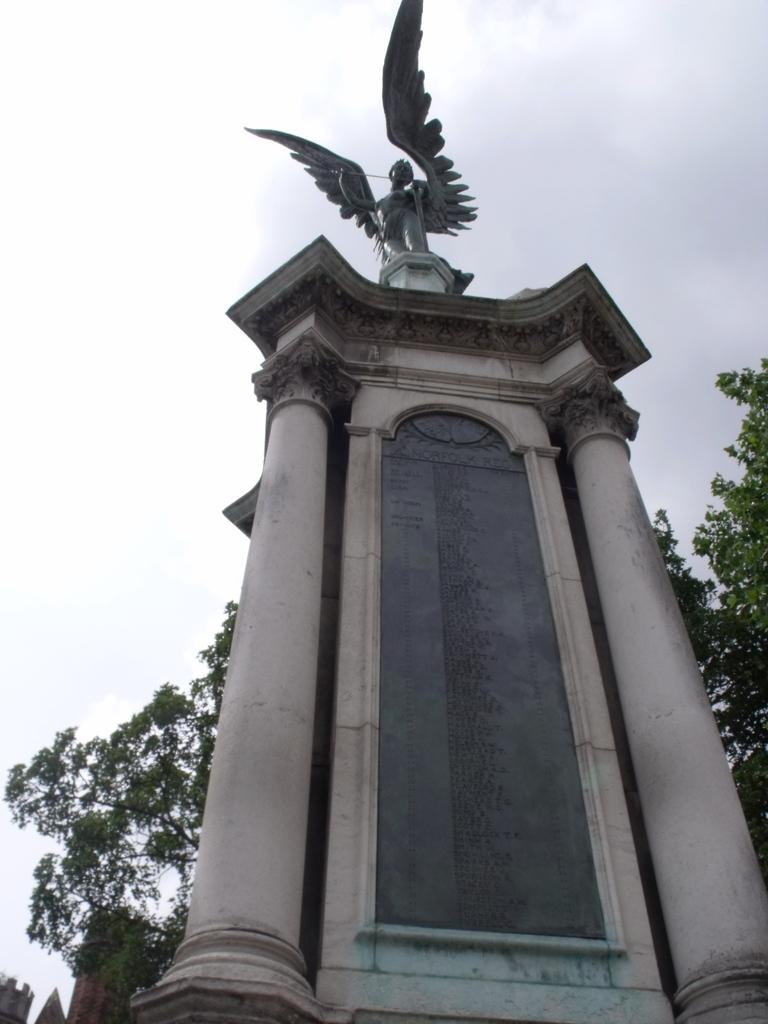What type of structure is located on the right side of the image? A: There is a stone structure on the right side of the image. What is on top of the stone structure? There is a statue on the stone structure. What can be seen in the background of the image? There are trees in the background of the image. What type of balloon is floating near the statue in the image? There is no balloon present in the image; it only features a stone structure with a statue on top and trees in the background. 